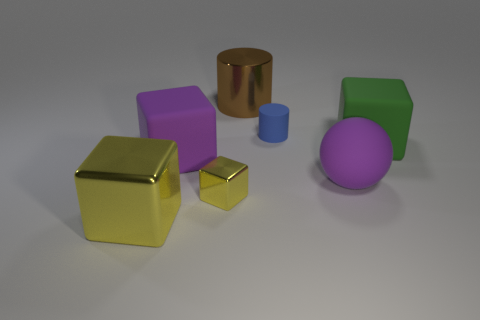Subtract all red cylinders. How many yellow cubes are left? 2 Subtract all large green blocks. How many blocks are left? 3 Add 1 big cylinders. How many objects exist? 8 Subtract all purple blocks. How many blocks are left? 3 Subtract all blocks. How many objects are left? 3 Subtract all purple blocks. Subtract all brown spheres. How many blocks are left? 3 Add 6 green matte blocks. How many green matte blocks are left? 7 Add 2 yellow objects. How many yellow objects exist? 4 Subtract 0 red cylinders. How many objects are left? 7 Subtract all tiny green rubber things. Subtract all big brown things. How many objects are left? 6 